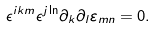Convert formula to latex. <formula><loc_0><loc_0><loc_500><loc_500>\epsilon ^ { i k m } \epsilon ^ { j \ln } \partial _ { k } \partial _ { l } \varepsilon _ { m n } = 0 .</formula> 